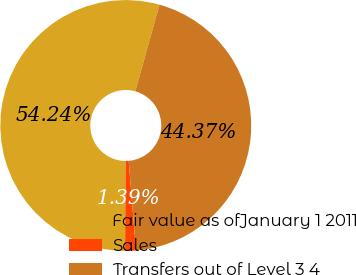Convert chart. <chart><loc_0><loc_0><loc_500><loc_500><pie_chart><fcel>Fair value as ofJanuary 1 2011<fcel>Sales<fcel>Transfers out of Level 3 4<nl><fcel>54.25%<fcel>1.39%<fcel>44.37%<nl></chart> 